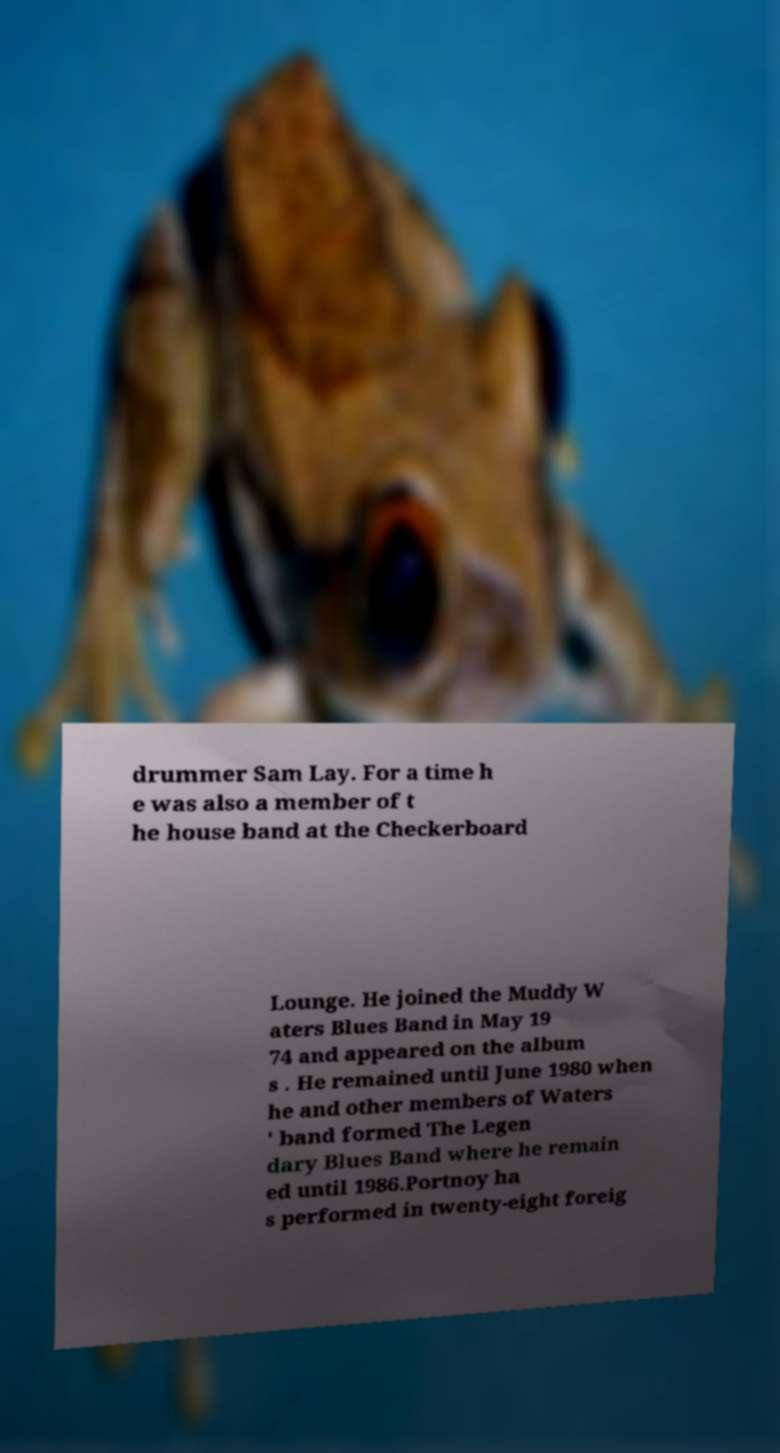Can you read and provide the text displayed in the image?This photo seems to have some interesting text. Can you extract and type it out for me? drummer Sam Lay. For a time h e was also a member of t he house band at the Checkerboard Lounge. He joined the Muddy W aters Blues Band in May 19 74 and appeared on the album s . He remained until June 1980 when he and other members of Waters ' band formed The Legen dary Blues Band where he remain ed until 1986.Portnoy ha s performed in twenty-eight foreig 